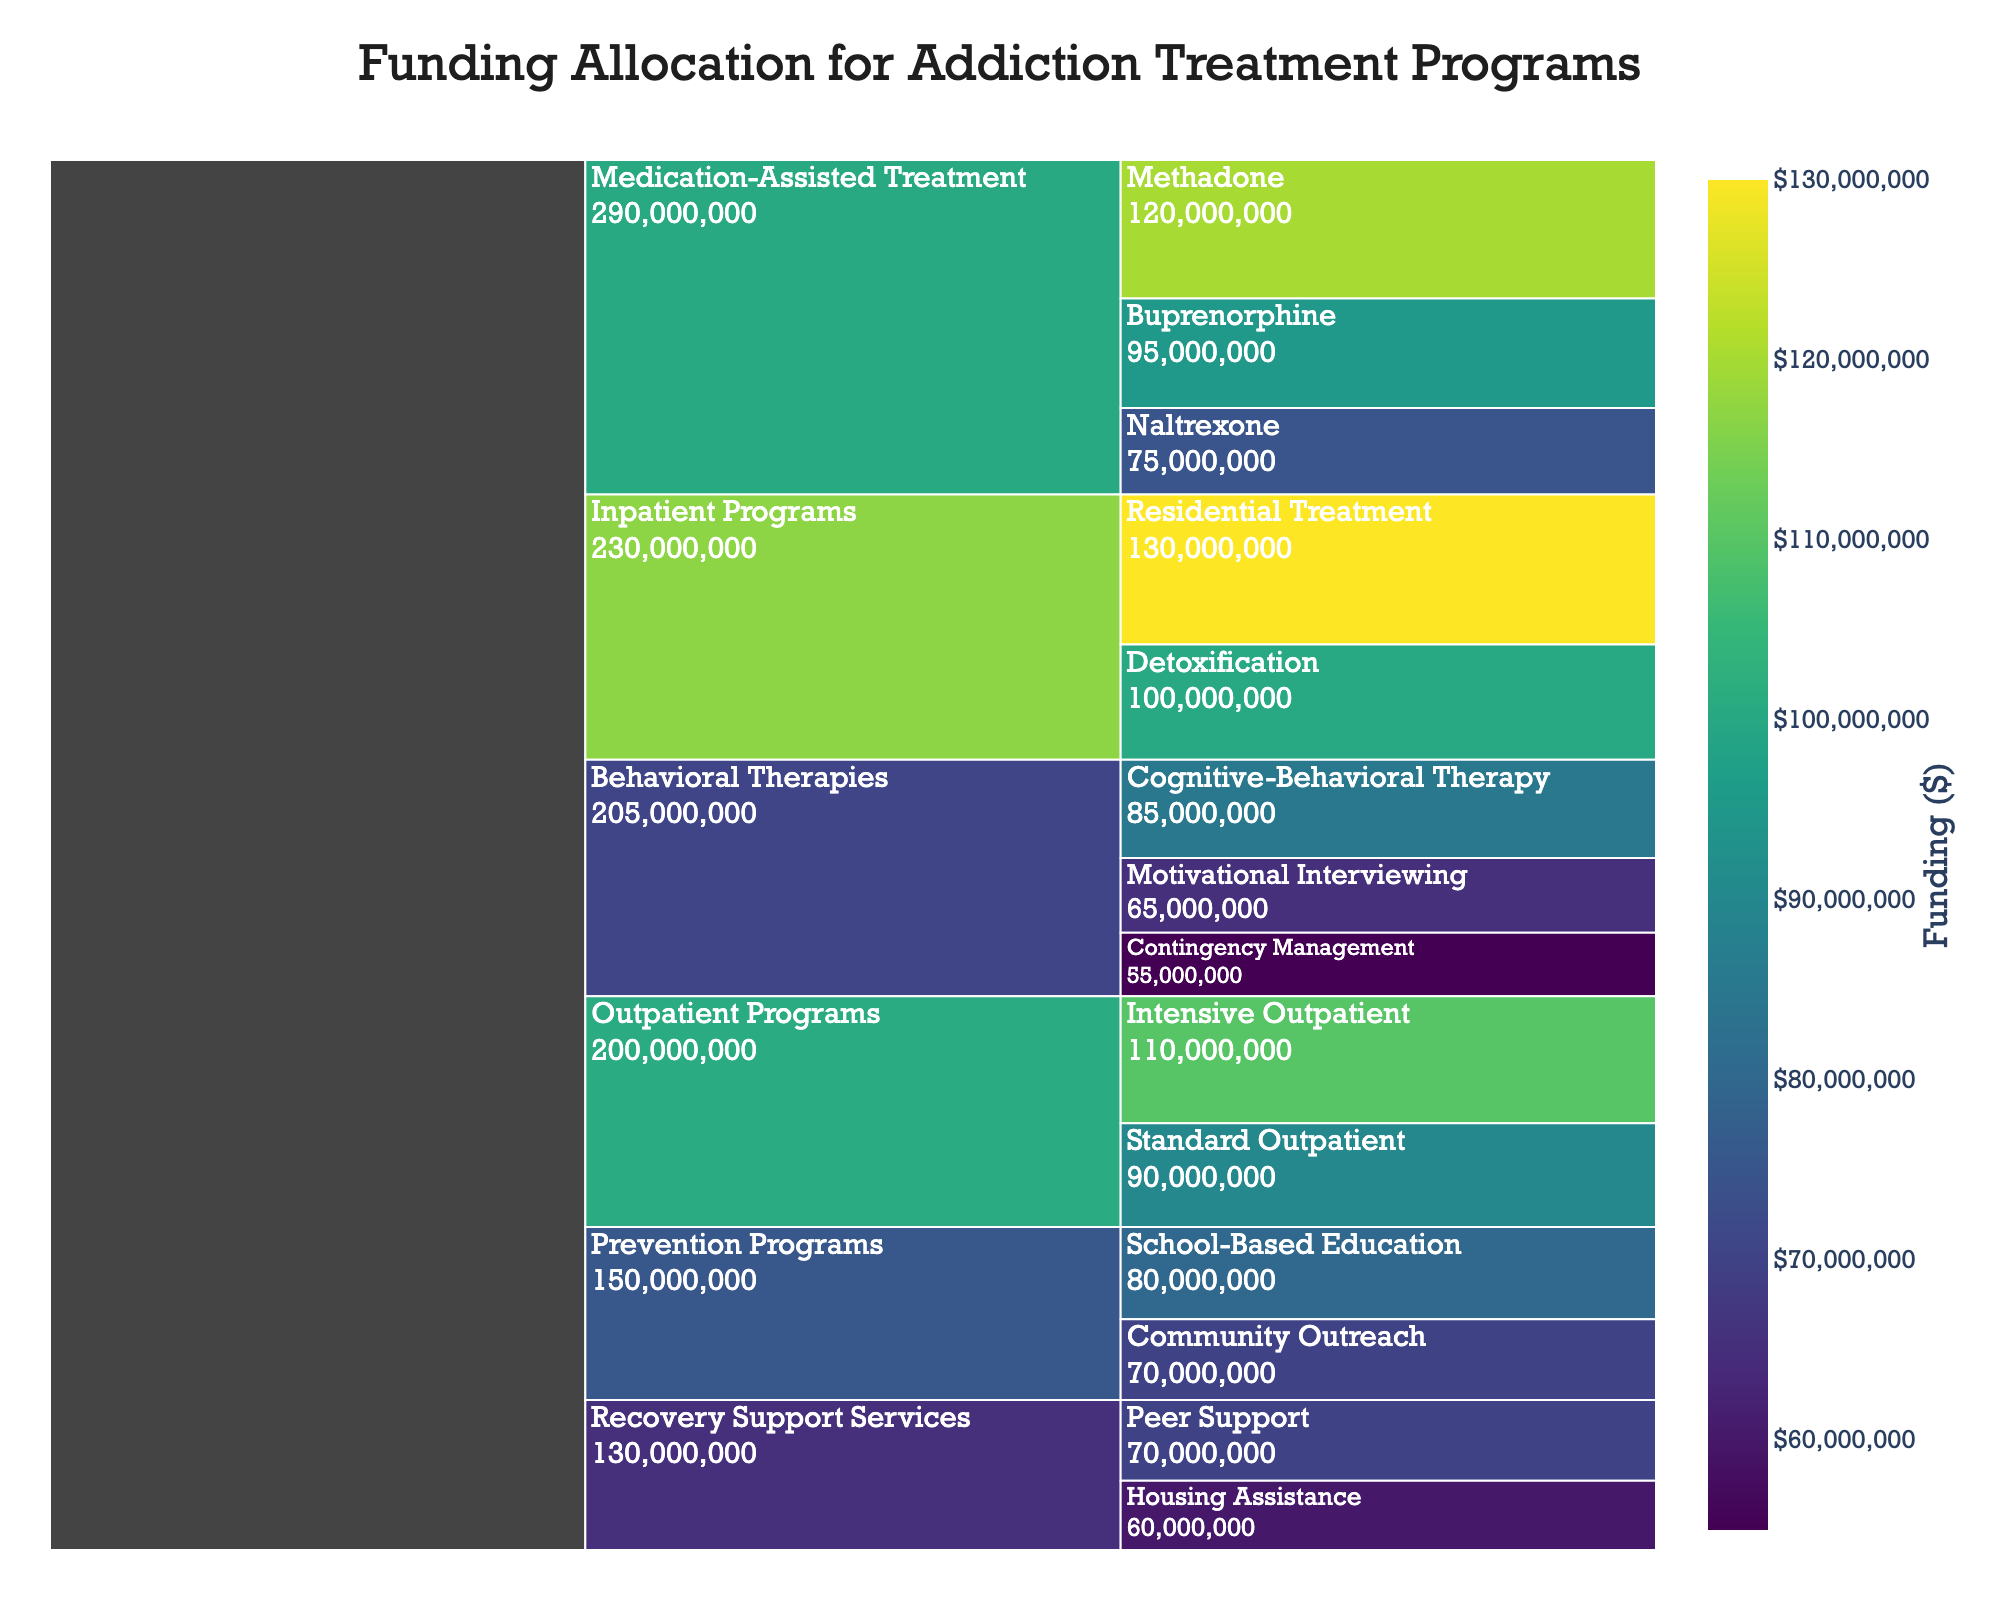What's the title of the figure? The title is typically displayed prominently at the top of the chart. In this case, it is set as "Funding Allocation for Addiction Treatment Programs."
Answer: Funding Allocation for Addiction Treatment Programs Which treatment type received the most funding? By examining the chart, you can identify the category with the largest segment, which indicates the highest funding. Here, "Inpatient Programs" under "Residential Treatment" received the highest funding of $130,000,000.
Answer: Residential Treatment How much funding was allocated to Naltrexone under Medication-Assisted Treatment? By following the path leading from "Medication-Assisted Treatment" to "Naltrexone," you will find the allocated funding for this subcategory, which is $75,000,000.
Answer: $75,000,000 What is the total funding for all Behavioral Therapies combined? To calculate this, sum the funding amounts for all subcategories within "Behavioral Therapies": Cognitive-Behavioral Therapy ($85,000,000) + Motivational Interviewing ($65,000,000) + Contingency Management ($55,000,000). The total is $205,000,000.
Answer: $205,000,000 Which subcategory has the least amount of funding in the Outpatient Programs category? By examining the segments within "Outpatient Programs," you can see that "Standard Outpatient" has a smaller segment compared to "Intensive Outpatient," with the funding amount being $90,000,000.
Answer: Standard Outpatient Compare the funding for Methadone vs Buprenorphine under Medication-Assisted Treatment. Which has more? Compare the funding amounts for both subcategories within "Medication-Assisted Treatment": Methadone ($120,000,000) and Buprenorphine ($95,000,000). Methadone has more funding.
Answer: Methadone How does the funding for School-Based Education compare to Community Outreach under Prevention Programs? By comparing the two subcategories within "Prevention Programs," you can see that School-Based Education has $80,000,000 while Community Outreach has $70,000,000. School-Based Education has more funding.
Answer: School-Based Education What is the average funding amount across all the subcategories? To find the average, sum all the funding amounts and divide by the number of subcategories. Total funding is $1,200,000,000 divided by 14 subcategories: $1,200,000,000/14 = $85,714,286.
Answer: $85,714,286 What is the combined funding for Recovery Support Services? Add the funding amounts of both subcategories within "Recovery Support Services": Peer Support ($70,000,000) + Housing Assistance ($60,000,000). The combined funding is $130,000,000.
Answer: $130,000,000 Identify the total allocation for Medication-Assisted Treatment programs. Summing the amounts for Methadone ($120,000,000), Buprenorphine ($95,000,000), and Naltrexone ($75,000,000) within Medication-Assisted Treatment provides the total: $290,000,000.
Answer: $290,000,000 